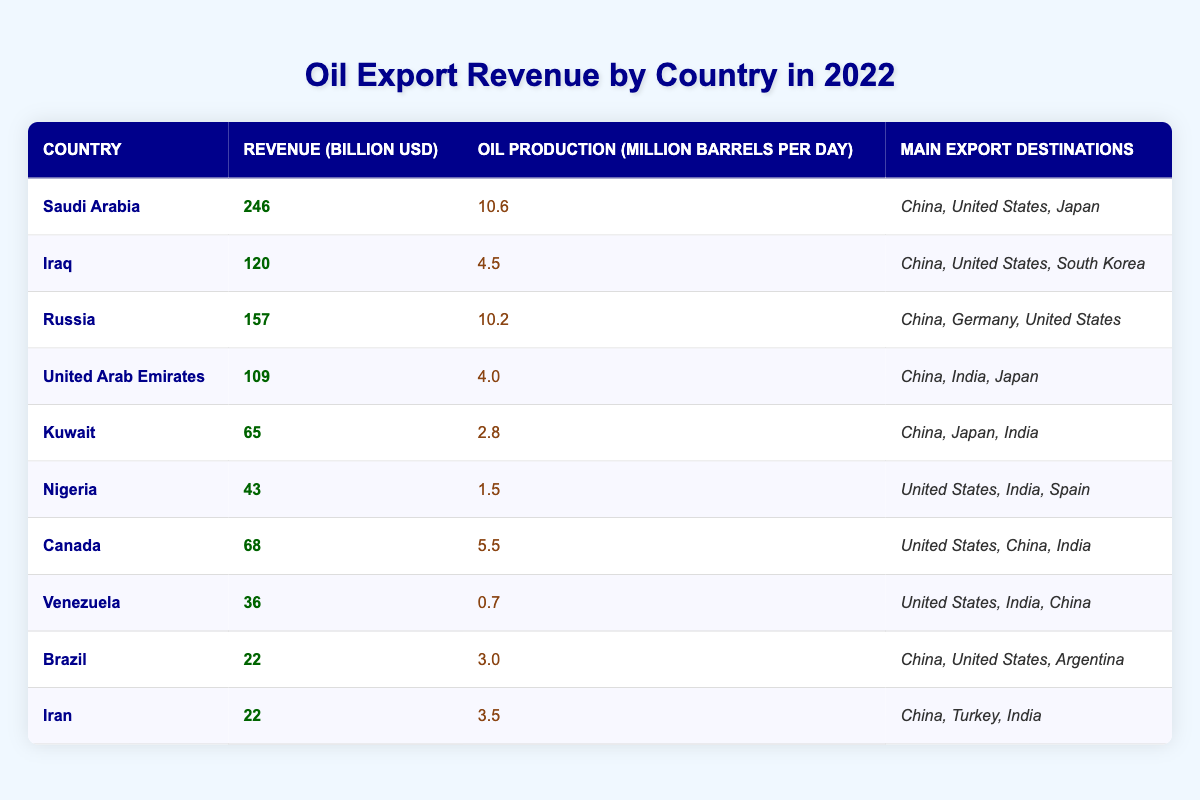What country had the highest oil export revenue in 2022? By looking at the "Revenue (Billion USD)" column, Saudi Arabia has the highest revenue at 246 billion USD.
Answer: Saudi Arabia What was the oil production of Iraq in million barrels per day? The table shows that Iraq produced 4.5 million barrels per day.
Answer: 4.5 Which country had the lowest oil export revenue? Venezuela is listed with the lowest revenue at 36 billion USD according to the "Revenue (Billion USD)" column.
Answer: Venezuela What is the total oil export revenue of the top three countries? Adding the revenues: Saudi Arabia (246) + Russia (157) + Iraq (120) equals 523 billion USD.
Answer: 523 Who are the main export destinations for Canada? The table indicates that Canada's main export destinations are the United States, China, and India.
Answer: United States, China, India Is it true that Iran had the same revenue as Brazil? Both Iran and Brazil have a revenue of 22 billion USD, so the statement is true.
Answer: True What would be the average revenue of the countries listed in the table? Total revenue is (246 + 120 + 157 + 109 + 65 + 43 + 68 + 36 + 22 + 22) =  888 billion USD. Dividing by 10 countries gives an average of 88.8 billion USD.
Answer: 88.8 Which country produces more oil, Kuwait or Nigeria? Kuwait produces 2.8 million barrels per day, while Nigeria produces 1.5 million barrels per day, so Kuwait produces more oil.
Answer: Kuwait How much more revenue does Russia have compared to Nigeria? The difference in revenue is 157 billion (Russia) - 43 billion (Nigeria) = 114 billion USD.
Answer: 114 Which countries have China as a main export destination? According to the "Main Export Destinations" column, the countries that list China are Saudi Arabia, Iraq, United Arab Emirates, Kuwait, Brazil, and Iran.
Answer: Saudi Arabia, Iraq, United Arab Emirates, Kuwait, Brazil, Iran 